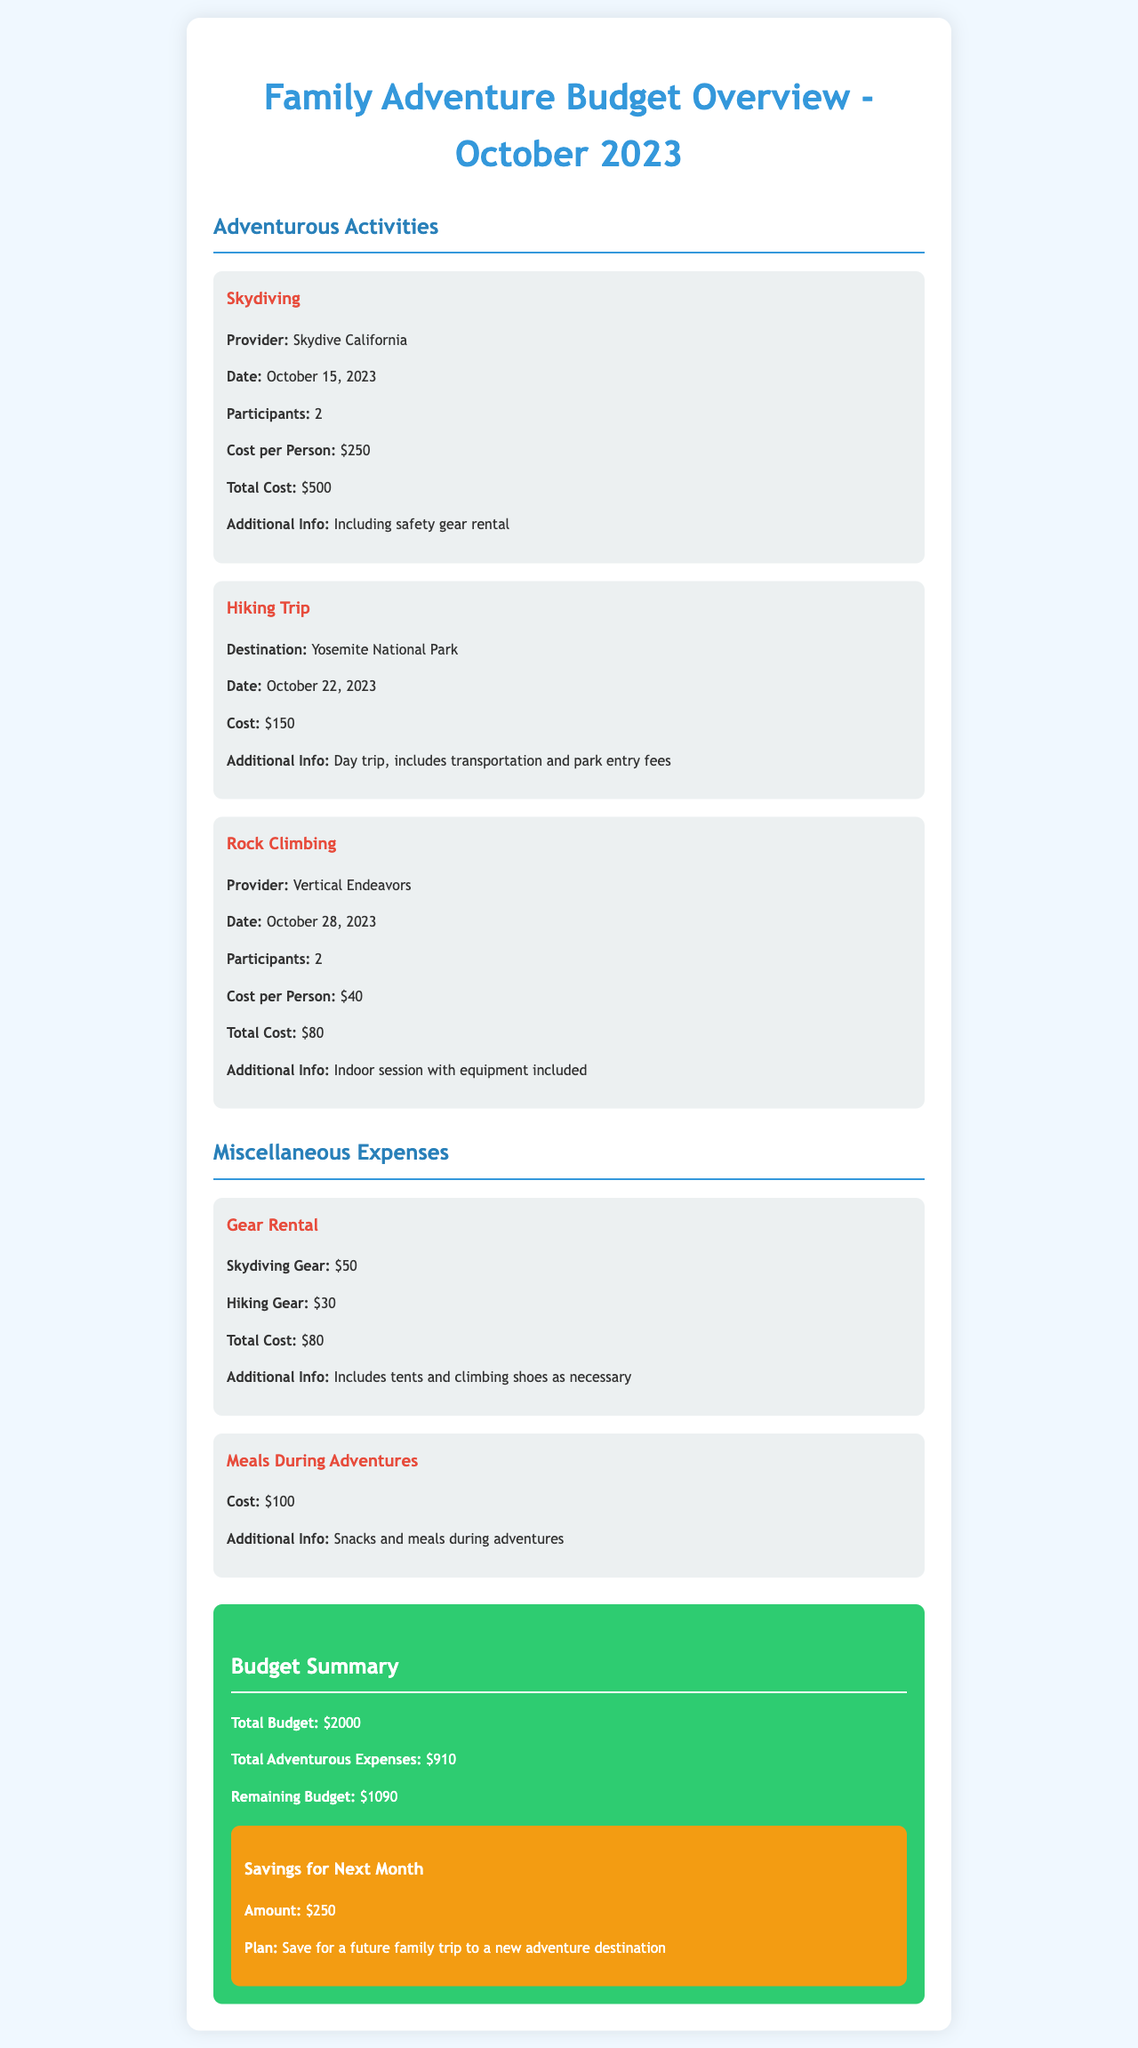What is the total cost of skydiving? The total cost of skydiving is specifically mentioned in the document under the Skydiving section.
Answer: $500 How many participants are there in the rock climbing activity? The number of participants for the rock climbing activity is stated in the respective section.
Answer: 2 What is the scheduled date for the hiking trip? The date for the hiking trip is listed in the Hiking Trip section.
Answer: October 22, 2023 What is the total amount spent on gear rental? The total cost for gear rental is summarized in the Gear Rental section of the document.
Answer: $80 What is the remaining budget after adventurous expenses? The remaining budget is calculated by subtracting total adventurous expenses from the total budget.
Answer: $1090 What is the total cost for meals during adventures? The cost for meals during adventures is mentioned in the Meals During Adventures section.
Answer: $100 What adventure is planned for October 28, 2023? The specific adventure planned for that date is mentioned in the respective section.
Answer: Rock Climbing What is the cost per person for skydiving? The cost per person for skydiving is provided in the Skydiving section.
Answer: $250 What is the plan for savings next month? The plan for savings is outlined in the savings portion of the budget summary.
Answer: Save for a future family trip to a new adventure destination 